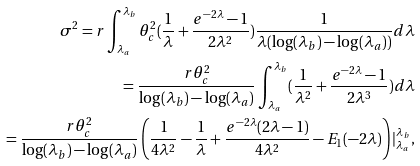<formula> <loc_0><loc_0><loc_500><loc_500>\sigma ^ { 2 } = r \int _ { \lambda _ { a } } ^ { \lambda _ { b } } \theta _ { c } ^ { 2 } ( \frac { 1 } { \lambda } + \frac { e ^ { - 2 \lambda } - 1 } { 2 \lambda ^ { 2 } } ) \frac { 1 } { \lambda ( \log ( \lambda _ { b } ) - \log ( \lambda _ { a } ) ) } d \lambda \\ = \frac { r \theta _ { c } ^ { 2 } } { \log ( \lambda _ { b } ) - \log ( \lambda _ { a } ) } \int _ { \lambda _ { a } } ^ { \lambda _ { b } } ( \frac { 1 } { \lambda ^ { 2 } } + \frac { e ^ { - 2 \lambda } - 1 } { 2 \lambda ^ { 3 } } ) d \lambda \\ = \frac { r \theta _ { c } ^ { 2 } } { \log ( \lambda _ { b } ) - \log ( \lambda _ { a } ) } \left ( \frac { 1 } { 4 \lambda ^ { 2 } } - \frac { 1 } { \lambda } + \frac { e ^ { - 2 \lambda } ( 2 \lambda - 1 ) } { 4 \lambda ^ { 2 } } - E _ { 1 } ( - 2 \lambda ) \right ) | _ { \lambda _ { a } } ^ { \lambda _ { b } } ,</formula> 